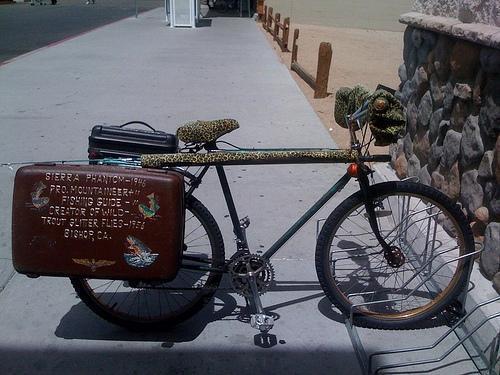What design is the bike seat?
From the following set of four choices, select the accurate answer to respond to the question.
Options: Leopard print, stripes, zebra print, plaid. Leopard print. 